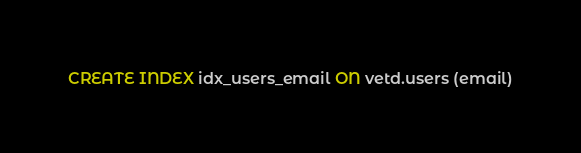<code> <loc_0><loc_0><loc_500><loc_500><_SQL_>CREATE INDEX idx_users_email ON vetd.users (email)</code> 